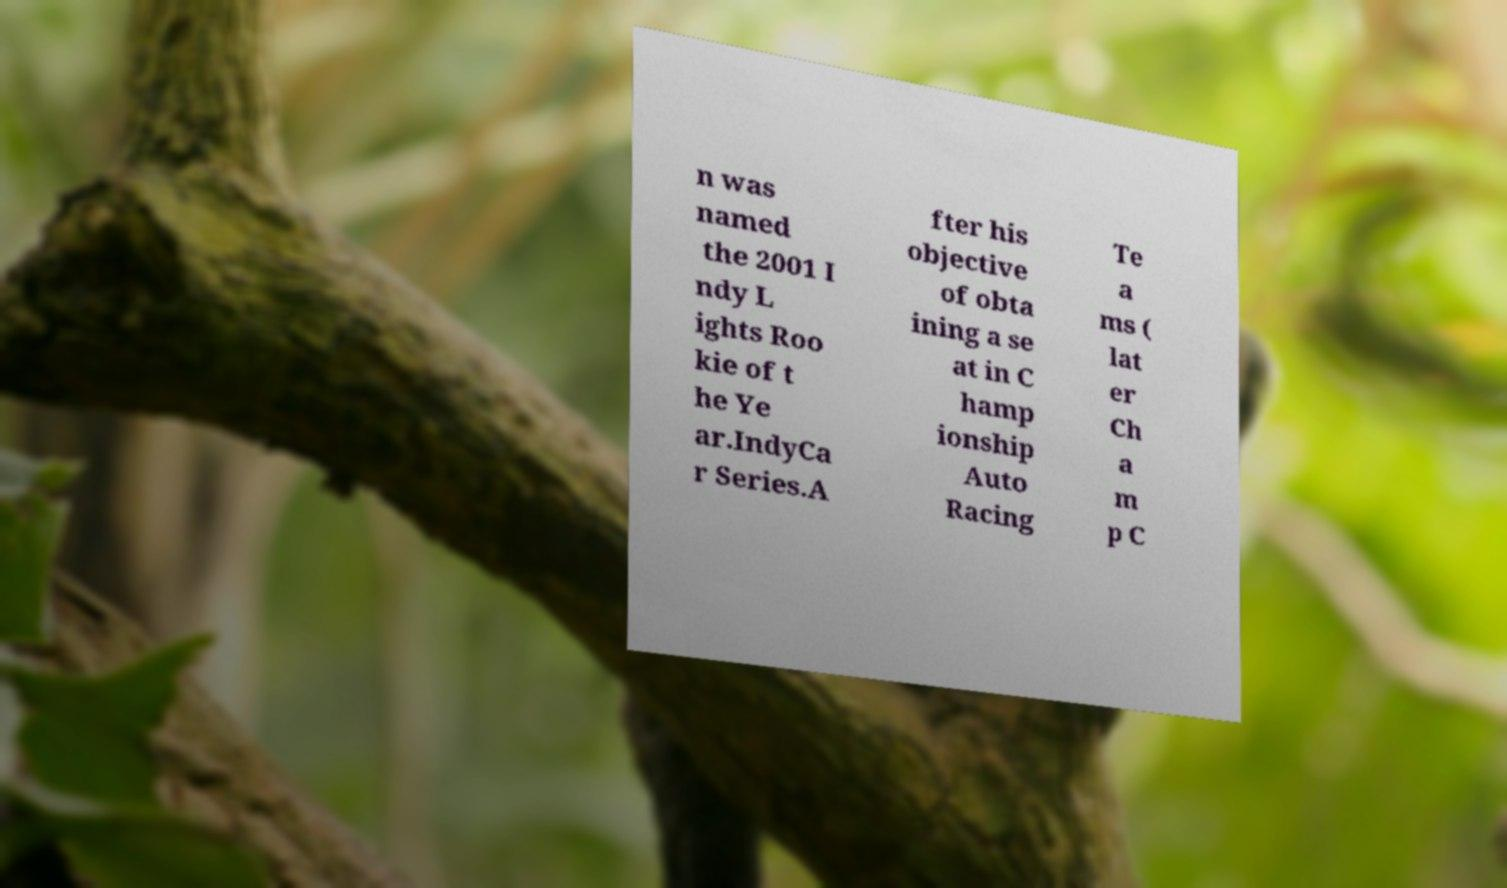Please read and relay the text visible in this image. What does it say? n was named the 2001 I ndy L ights Roo kie of t he Ye ar.IndyCa r Series.A fter his objective of obta ining a se at in C hamp ionship Auto Racing Te a ms ( lat er Ch a m p C 